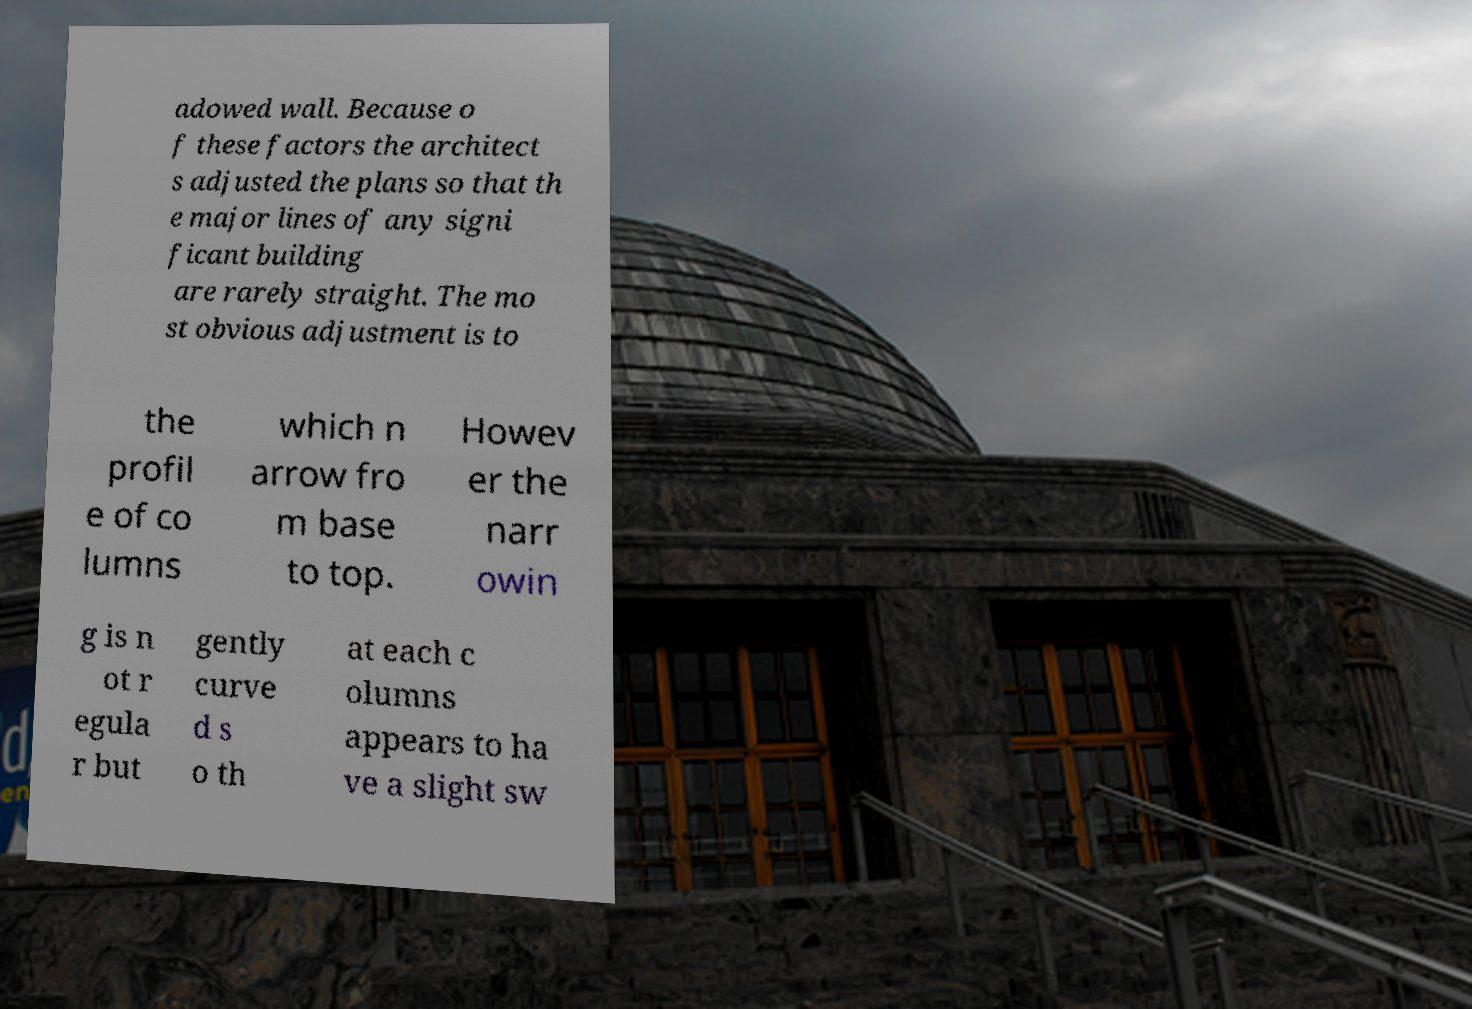For documentation purposes, I need the text within this image transcribed. Could you provide that? adowed wall. Because o f these factors the architect s adjusted the plans so that th e major lines of any signi ficant building are rarely straight. The mo st obvious adjustment is to the profil e of co lumns which n arrow fro m base to top. Howev er the narr owin g is n ot r egula r but gently curve d s o th at each c olumns appears to ha ve a slight sw 